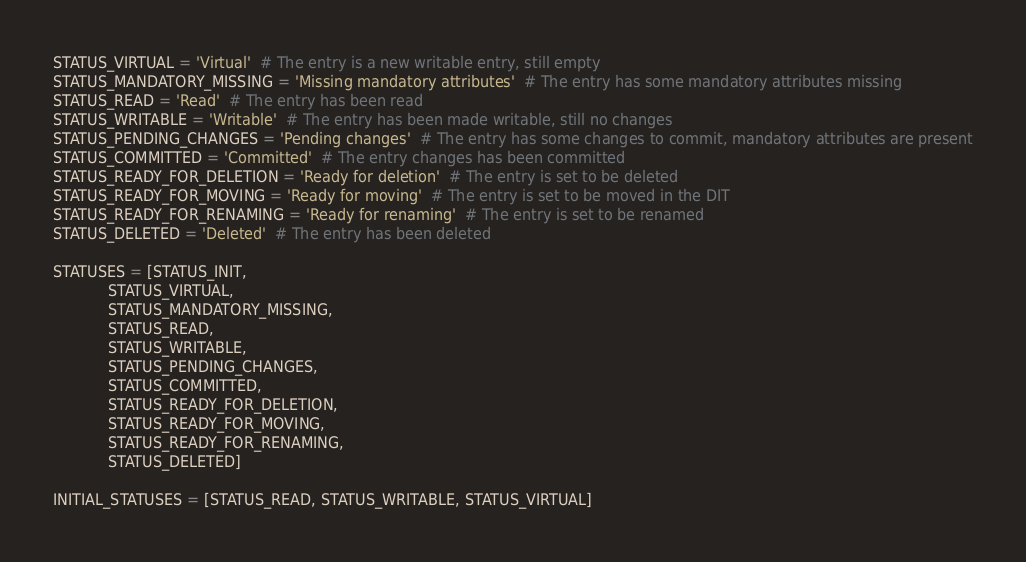Convert code to text. <code><loc_0><loc_0><loc_500><loc_500><_Python_>STATUS_VIRTUAL = 'Virtual'  # The entry is a new writable entry, still empty
STATUS_MANDATORY_MISSING = 'Missing mandatory attributes'  # The entry has some mandatory attributes missing
STATUS_READ = 'Read'  # The entry has been read
STATUS_WRITABLE = 'Writable'  # The entry has been made writable, still no changes
STATUS_PENDING_CHANGES = 'Pending changes'  # The entry has some changes to commit, mandatory attributes are present
STATUS_COMMITTED = 'Committed'  # The entry changes has been committed
STATUS_READY_FOR_DELETION = 'Ready for deletion'  # The entry is set to be deleted
STATUS_READY_FOR_MOVING = 'Ready for moving'  # The entry is set to be moved in the DIT
STATUS_READY_FOR_RENAMING = 'Ready for renaming'  # The entry is set to be renamed
STATUS_DELETED = 'Deleted'  # The entry has been deleted

STATUSES = [STATUS_INIT,
            STATUS_VIRTUAL,
            STATUS_MANDATORY_MISSING,
            STATUS_READ,
            STATUS_WRITABLE,
            STATUS_PENDING_CHANGES,
            STATUS_COMMITTED,
            STATUS_READY_FOR_DELETION,
            STATUS_READY_FOR_MOVING,
            STATUS_READY_FOR_RENAMING,
            STATUS_DELETED]

INITIAL_STATUSES = [STATUS_READ, STATUS_WRITABLE, STATUS_VIRTUAL]
</code> 